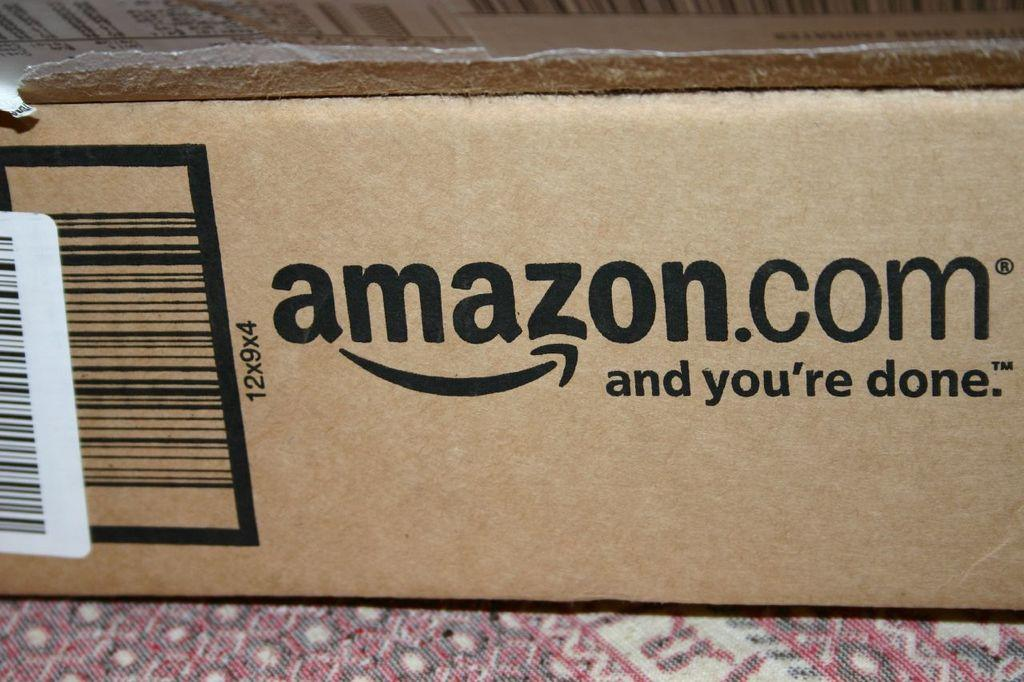<image>
Summarize the visual content of the image. An Amazon box is sitting on a multicolored surface. 